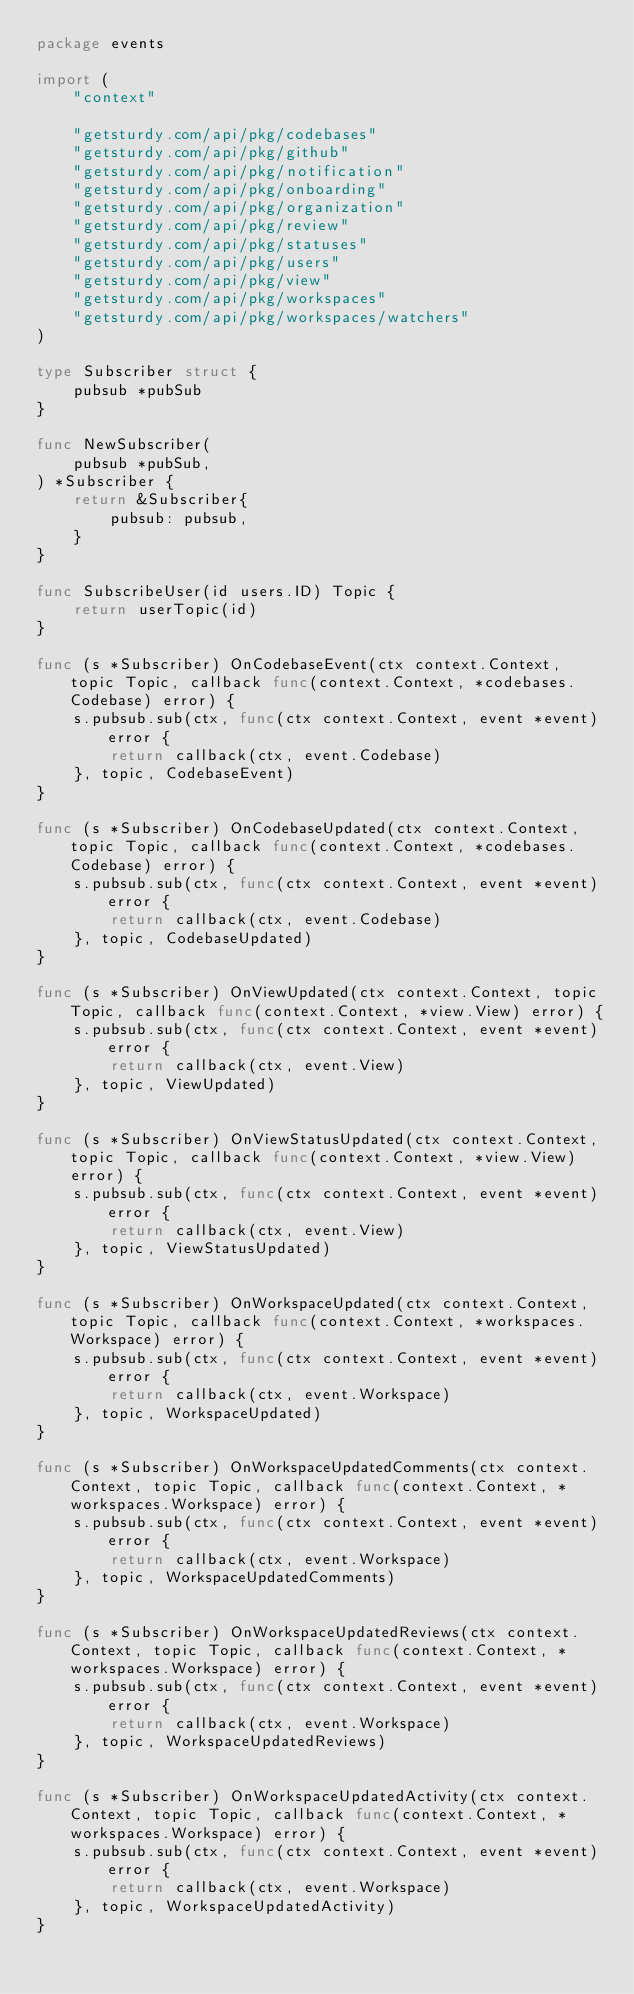Convert code to text. <code><loc_0><loc_0><loc_500><loc_500><_Go_>package events

import (
	"context"

	"getsturdy.com/api/pkg/codebases"
	"getsturdy.com/api/pkg/github"
	"getsturdy.com/api/pkg/notification"
	"getsturdy.com/api/pkg/onboarding"
	"getsturdy.com/api/pkg/organization"
	"getsturdy.com/api/pkg/review"
	"getsturdy.com/api/pkg/statuses"
	"getsturdy.com/api/pkg/users"
	"getsturdy.com/api/pkg/view"
	"getsturdy.com/api/pkg/workspaces"
	"getsturdy.com/api/pkg/workspaces/watchers"
)

type Subscriber struct {
	pubsub *pubSub
}

func NewSubscriber(
	pubsub *pubSub,
) *Subscriber {
	return &Subscriber{
		pubsub: pubsub,
	}
}

func SubscribeUser(id users.ID) Topic {
	return userTopic(id)
}

func (s *Subscriber) OnCodebaseEvent(ctx context.Context, topic Topic, callback func(context.Context, *codebases.Codebase) error) {
	s.pubsub.sub(ctx, func(ctx context.Context, event *event) error {
		return callback(ctx, event.Codebase)
	}, topic, CodebaseEvent)
}

func (s *Subscriber) OnCodebaseUpdated(ctx context.Context, topic Topic, callback func(context.Context, *codebases.Codebase) error) {
	s.pubsub.sub(ctx, func(ctx context.Context, event *event) error {
		return callback(ctx, event.Codebase)
	}, topic, CodebaseUpdated)
}

func (s *Subscriber) OnViewUpdated(ctx context.Context, topic Topic, callback func(context.Context, *view.View) error) {
	s.pubsub.sub(ctx, func(ctx context.Context, event *event) error {
		return callback(ctx, event.View)
	}, topic, ViewUpdated)
}

func (s *Subscriber) OnViewStatusUpdated(ctx context.Context, topic Topic, callback func(context.Context, *view.View) error) {
	s.pubsub.sub(ctx, func(ctx context.Context, event *event) error {
		return callback(ctx, event.View)
	}, topic, ViewStatusUpdated)
}

func (s *Subscriber) OnWorkspaceUpdated(ctx context.Context, topic Topic, callback func(context.Context, *workspaces.Workspace) error) {
	s.pubsub.sub(ctx, func(ctx context.Context, event *event) error {
		return callback(ctx, event.Workspace)
	}, topic, WorkspaceUpdated)
}

func (s *Subscriber) OnWorkspaceUpdatedComments(ctx context.Context, topic Topic, callback func(context.Context, *workspaces.Workspace) error) {
	s.pubsub.sub(ctx, func(ctx context.Context, event *event) error {
		return callback(ctx, event.Workspace)
	}, topic, WorkspaceUpdatedComments)
}

func (s *Subscriber) OnWorkspaceUpdatedReviews(ctx context.Context, topic Topic, callback func(context.Context, *workspaces.Workspace) error) {
	s.pubsub.sub(ctx, func(ctx context.Context, event *event) error {
		return callback(ctx, event.Workspace)
	}, topic, WorkspaceUpdatedReviews)
}

func (s *Subscriber) OnWorkspaceUpdatedActivity(ctx context.Context, topic Topic, callback func(context.Context, *workspaces.Workspace) error) {
	s.pubsub.sub(ctx, func(ctx context.Context, event *event) error {
		return callback(ctx, event.Workspace)
	}, topic, WorkspaceUpdatedActivity)
}
</code> 